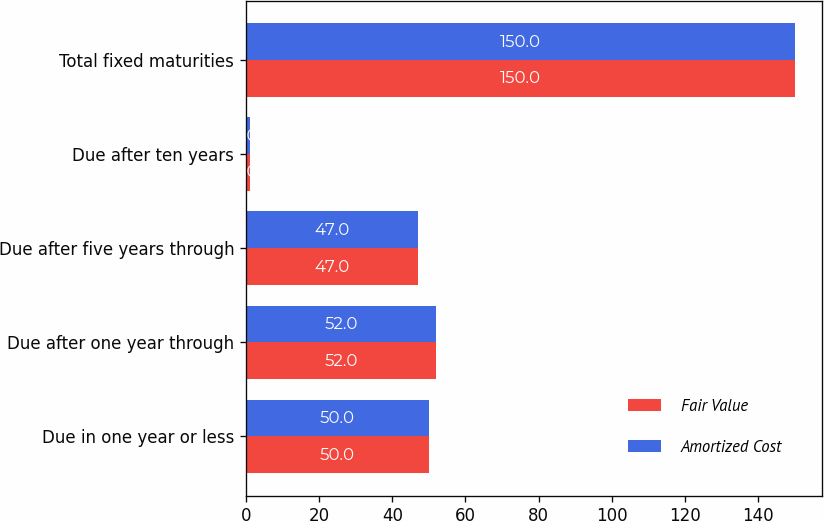Convert chart. <chart><loc_0><loc_0><loc_500><loc_500><stacked_bar_chart><ecel><fcel>Due in one year or less<fcel>Due after one year through<fcel>Due after five years through<fcel>Due after ten years<fcel>Total fixed maturities<nl><fcel>Fair Value<fcel>50<fcel>52<fcel>47<fcel>1<fcel>150<nl><fcel>Amortized Cost<fcel>50<fcel>52<fcel>47<fcel>1<fcel>150<nl></chart> 